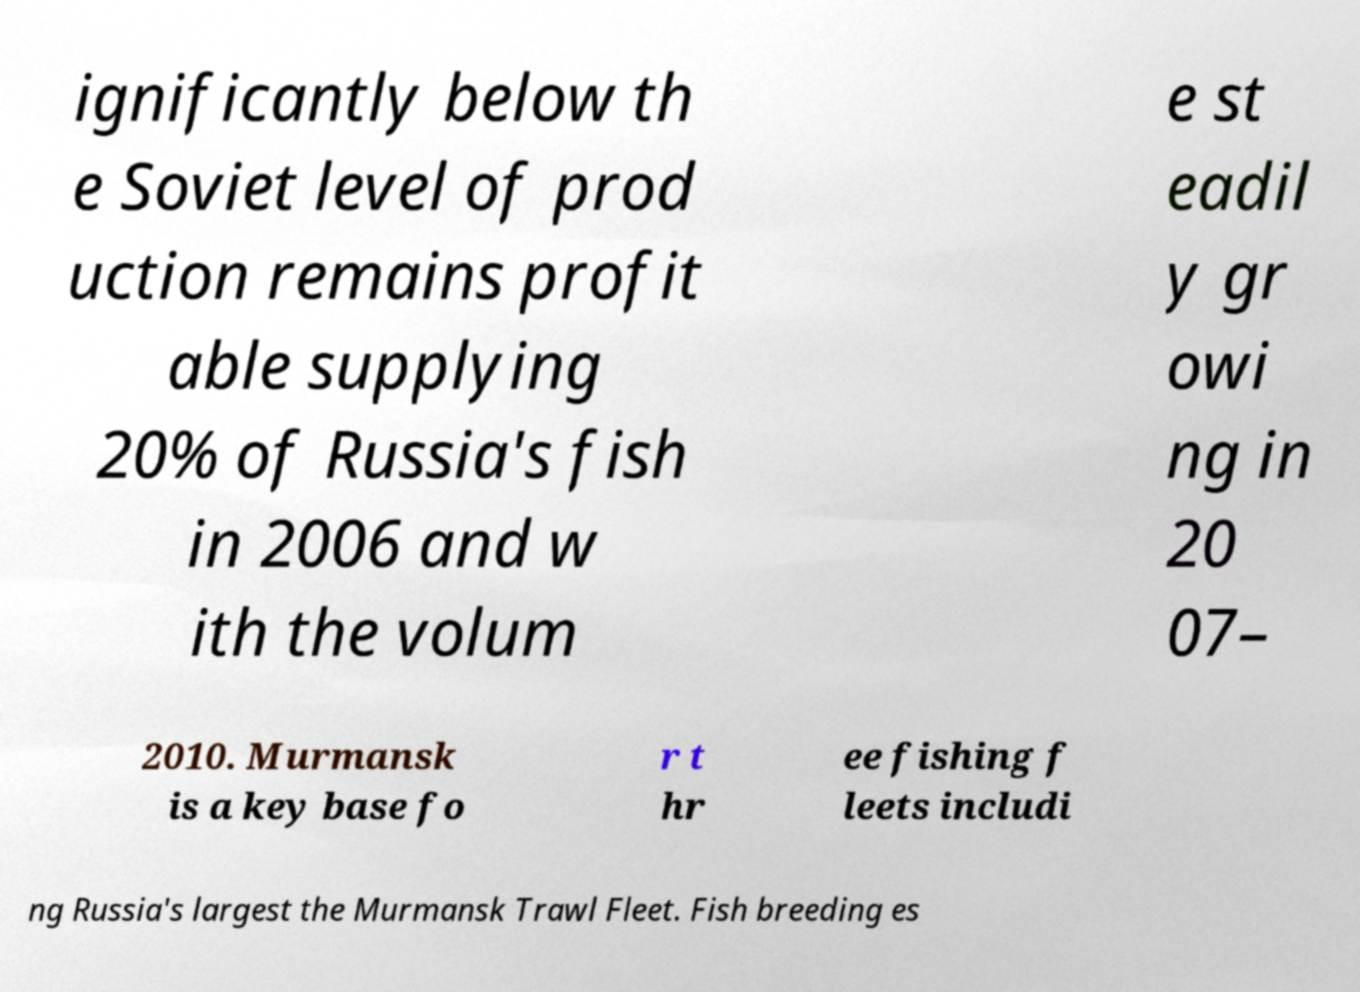Could you extract and type out the text from this image? ignificantly below th e Soviet level of prod uction remains profit able supplying 20% of Russia's fish in 2006 and w ith the volum e st eadil y gr owi ng in 20 07– 2010. Murmansk is a key base fo r t hr ee fishing f leets includi ng Russia's largest the Murmansk Trawl Fleet. Fish breeding es 